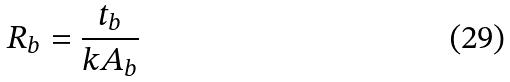Convert formula to latex. <formula><loc_0><loc_0><loc_500><loc_500>R _ { b } = \frac { t _ { b } } { k A _ { b } }</formula> 